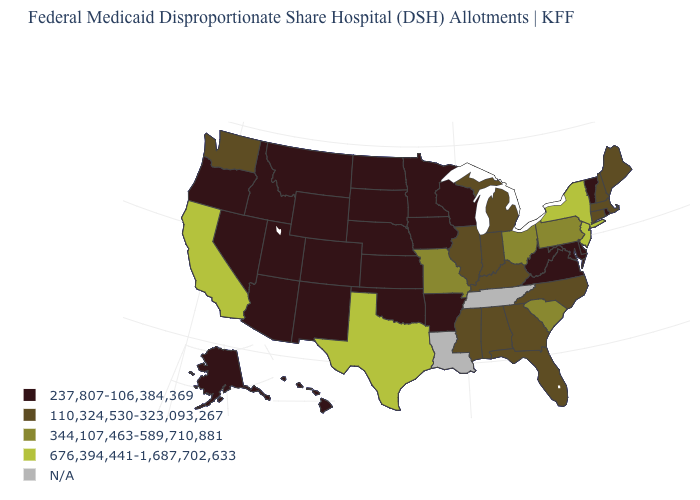Name the states that have a value in the range 237,807-106,384,369?
Concise answer only. Alaska, Arizona, Arkansas, Colorado, Delaware, Hawaii, Idaho, Iowa, Kansas, Maryland, Minnesota, Montana, Nebraska, Nevada, New Mexico, North Dakota, Oklahoma, Oregon, Rhode Island, South Dakota, Utah, Vermont, Virginia, West Virginia, Wisconsin, Wyoming. What is the value of Ohio?
Be succinct. 344,107,463-589,710,881. What is the value of Tennessee?
Short answer required. N/A. How many symbols are there in the legend?
Concise answer only. 5. How many symbols are there in the legend?
Give a very brief answer. 5. Which states hav the highest value in the Northeast?
Keep it brief. New Jersey, New York. Name the states that have a value in the range 344,107,463-589,710,881?
Answer briefly. Missouri, Ohio, Pennsylvania, South Carolina. What is the highest value in the South ?
Be succinct. 676,394,441-1,687,702,633. What is the value of Utah?
Concise answer only. 237,807-106,384,369. Among the states that border Nevada , does Idaho have the highest value?
Keep it brief. No. Which states hav the highest value in the Northeast?
Keep it brief. New Jersey, New York. Name the states that have a value in the range 344,107,463-589,710,881?
Concise answer only. Missouri, Ohio, Pennsylvania, South Carolina. Name the states that have a value in the range N/A?
Concise answer only. Louisiana, Tennessee. What is the lowest value in the USA?
Write a very short answer. 237,807-106,384,369. Name the states that have a value in the range 237,807-106,384,369?
Concise answer only. Alaska, Arizona, Arkansas, Colorado, Delaware, Hawaii, Idaho, Iowa, Kansas, Maryland, Minnesota, Montana, Nebraska, Nevada, New Mexico, North Dakota, Oklahoma, Oregon, Rhode Island, South Dakota, Utah, Vermont, Virginia, West Virginia, Wisconsin, Wyoming. 